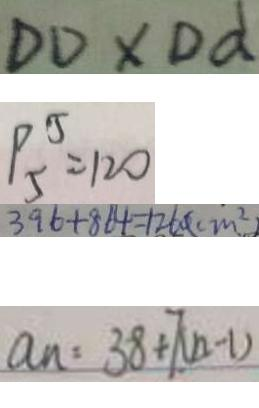<formula> <loc_0><loc_0><loc_500><loc_500>D D \times D d 
 P _ { 5 } ^ { 5 } = 1 2 0 
 3 9 6 + 8 6 4 = 1 2 6 0 ( c m ^ { 2 } ) 
 a _ { n } = 3 8 + 7 ( n - 1 )</formula> 